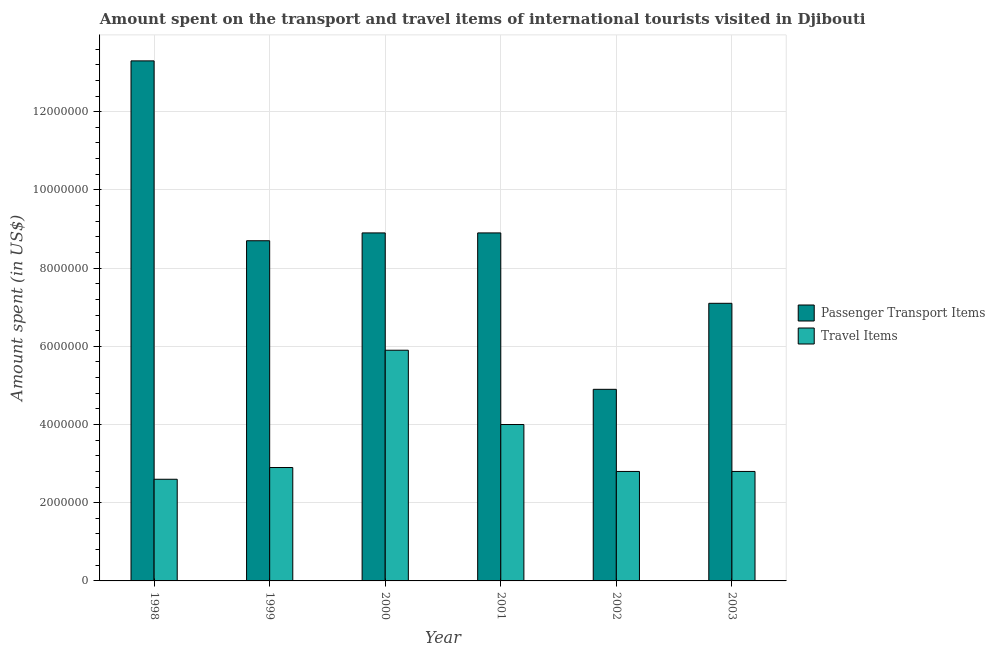How many groups of bars are there?
Your answer should be very brief. 6. What is the label of the 5th group of bars from the left?
Ensure brevity in your answer.  2002. What is the amount spent in travel items in 1999?
Provide a succinct answer. 2.90e+06. Across all years, what is the maximum amount spent in travel items?
Keep it short and to the point. 5.90e+06. Across all years, what is the minimum amount spent on passenger transport items?
Provide a short and direct response. 4.90e+06. What is the total amount spent in travel items in the graph?
Provide a succinct answer. 2.10e+07. What is the difference between the amount spent on passenger transport items in 1998 and that in 2002?
Provide a succinct answer. 8.40e+06. What is the difference between the amount spent in travel items in 1998 and the amount spent on passenger transport items in 1999?
Provide a succinct answer. -3.00e+05. What is the average amount spent on passenger transport items per year?
Offer a very short reply. 8.63e+06. In the year 1998, what is the difference between the amount spent on passenger transport items and amount spent in travel items?
Provide a short and direct response. 0. In how many years, is the amount spent on passenger transport items greater than 10400000 US$?
Ensure brevity in your answer.  1. What is the ratio of the amount spent in travel items in 1998 to that in 2003?
Give a very brief answer. 0.93. Is the difference between the amount spent on passenger transport items in 2000 and 2002 greater than the difference between the amount spent in travel items in 2000 and 2002?
Keep it short and to the point. No. What is the difference between the highest and the second highest amount spent on passenger transport items?
Keep it short and to the point. 4.40e+06. What is the difference between the highest and the lowest amount spent on passenger transport items?
Offer a very short reply. 8.40e+06. Is the sum of the amount spent on passenger transport items in 1999 and 2000 greater than the maximum amount spent in travel items across all years?
Give a very brief answer. Yes. What does the 1st bar from the left in 2000 represents?
Ensure brevity in your answer.  Passenger Transport Items. What does the 2nd bar from the right in 2001 represents?
Keep it short and to the point. Passenger Transport Items. Are all the bars in the graph horizontal?
Keep it short and to the point. No. How many years are there in the graph?
Your answer should be very brief. 6. What is the difference between two consecutive major ticks on the Y-axis?
Your response must be concise. 2.00e+06. Are the values on the major ticks of Y-axis written in scientific E-notation?
Offer a terse response. No. Where does the legend appear in the graph?
Your answer should be compact. Center right. How many legend labels are there?
Keep it short and to the point. 2. What is the title of the graph?
Ensure brevity in your answer.  Amount spent on the transport and travel items of international tourists visited in Djibouti. What is the label or title of the X-axis?
Keep it short and to the point. Year. What is the label or title of the Y-axis?
Keep it short and to the point. Amount spent (in US$). What is the Amount spent (in US$) of Passenger Transport Items in 1998?
Your answer should be compact. 1.33e+07. What is the Amount spent (in US$) of Travel Items in 1998?
Your answer should be compact. 2.60e+06. What is the Amount spent (in US$) of Passenger Transport Items in 1999?
Your answer should be compact. 8.70e+06. What is the Amount spent (in US$) of Travel Items in 1999?
Your response must be concise. 2.90e+06. What is the Amount spent (in US$) of Passenger Transport Items in 2000?
Make the answer very short. 8.90e+06. What is the Amount spent (in US$) in Travel Items in 2000?
Provide a short and direct response. 5.90e+06. What is the Amount spent (in US$) in Passenger Transport Items in 2001?
Keep it short and to the point. 8.90e+06. What is the Amount spent (in US$) in Travel Items in 2001?
Offer a terse response. 4.00e+06. What is the Amount spent (in US$) in Passenger Transport Items in 2002?
Ensure brevity in your answer.  4.90e+06. What is the Amount spent (in US$) of Travel Items in 2002?
Make the answer very short. 2.80e+06. What is the Amount spent (in US$) in Passenger Transport Items in 2003?
Ensure brevity in your answer.  7.10e+06. What is the Amount spent (in US$) of Travel Items in 2003?
Your answer should be compact. 2.80e+06. Across all years, what is the maximum Amount spent (in US$) of Passenger Transport Items?
Provide a short and direct response. 1.33e+07. Across all years, what is the maximum Amount spent (in US$) of Travel Items?
Provide a short and direct response. 5.90e+06. Across all years, what is the minimum Amount spent (in US$) in Passenger Transport Items?
Give a very brief answer. 4.90e+06. Across all years, what is the minimum Amount spent (in US$) in Travel Items?
Ensure brevity in your answer.  2.60e+06. What is the total Amount spent (in US$) of Passenger Transport Items in the graph?
Offer a terse response. 5.18e+07. What is the total Amount spent (in US$) in Travel Items in the graph?
Ensure brevity in your answer.  2.10e+07. What is the difference between the Amount spent (in US$) of Passenger Transport Items in 1998 and that in 1999?
Keep it short and to the point. 4.60e+06. What is the difference between the Amount spent (in US$) in Passenger Transport Items in 1998 and that in 2000?
Provide a short and direct response. 4.40e+06. What is the difference between the Amount spent (in US$) in Travel Items in 1998 and that in 2000?
Provide a succinct answer. -3.30e+06. What is the difference between the Amount spent (in US$) in Passenger Transport Items in 1998 and that in 2001?
Keep it short and to the point. 4.40e+06. What is the difference between the Amount spent (in US$) of Travel Items in 1998 and that in 2001?
Provide a short and direct response. -1.40e+06. What is the difference between the Amount spent (in US$) of Passenger Transport Items in 1998 and that in 2002?
Ensure brevity in your answer.  8.40e+06. What is the difference between the Amount spent (in US$) in Travel Items in 1998 and that in 2002?
Offer a very short reply. -2.00e+05. What is the difference between the Amount spent (in US$) of Passenger Transport Items in 1998 and that in 2003?
Provide a succinct answer. 6.20e+06. What is the difference between the Amount spent (in US$) in Travel Items in 1998 and that in 2003?
Provide a short and direct response. -2.00e+05. What is the difference between the Amount spent (in US$) of Passenger Transport Items in 1999 and that in 2001?
Offer a very short reply. -2.00e+05. What is the difference between the Amount spent (in US$) of Travel Items in 1999 and that in 2001?
Provide a succinct answer. -1.10e+06. What is the difference between the Amount spent (in US$) of Passenger Transport Items in 1999 and that in 2002?
Keep it short and to the point. 3.80e+06. What is the difference between the Amount spent (in US$) in Travel Items in 1999 and that in 2002?
Ensure brevity in your answer.  1.00e+05. What is the difference between the Amount spent (in US$) in Passenger Transport Items in 1999 and that in 2003?
Your response must be concise. 1.60e+06. What is the difference between the Amount spent (in US$) in Passenger Transport Items in 2000 and that in 2001?
Give a very brief answer. 0. What is the difference between the Amount spent (in US$) in Travel Items in 2000 and that in 2001?
Your response must be concise. 1.90e+06. What is the difference between the Amount spent (in US$) of Passenger Transport Items in 2000 and that in 2002?
Offer a terse response. 4.00e+06. What is the difference between the Amount spent (in US$) in Travel Items in 2000 and that in 2002?
Keep it short and to the point. 3.10e+06. What is the difference between the Amount spent (in US$) of Passenger Transport Items in 2000 and that in 2003?
Keep it short and to the point. 1.80e+06. What is the difference between the Amount spent (in US$) in Travel Items in 2000 and that in 2003?
Keep it short and to the point. 3.10e+06. What is the difference between the Amount spent (in US$) in Passenger Transport Items in 2001 and that in 2002?
Offer a very short reply. 4.00e+06. What is the difference between the Amount spent (in US$) in Travel Items in 2001 and that in 2002?
Make the answer very short. 1.20e+06. What is the difference between the Amount spent (in US$) of Passenger Transport Items in 2001 and that in 2003?
Your response must be concise. 1.80e+06. What is the difference between the Amount spent (in US$) in Travel Items in 2001 and that in 2003?
Ensure brevity in your answer.  1.20e+06. What is the difference between the Amount spent (in US$) of Passenger Transport Items in 2002 and that in 2003?
Provide a short and direct response. -2.20e+06. What is the difference between the Amount spent (in US$) of Travel Items in 2002 and that in 2003?
Offer a terse response. 0. What is the difference between the Amount spent (in US$) of Passenger Transport Items in 1998 and the Amount spent (in US$) of Travel Items in 1999?
Your answer should be compact. 1.04e+07. What is the difference between the Amount spent (in US$) in Passenger Transport Items in 1998 and the Amount spent (in US$) in Travel Items in 2000?
Your response must be concise. 7.40e+06. What is the difference between the Amount spent (in US$) of Passenger Transport Items in 1998 and the Amount spent (in US$) of Travel Items in 2001?
Make the answer very short. 9.30e+06. What is the difference between the Amount spent (in US$) in Passenger Transport Items in 1998 and the Amount spent (in US$) in Travel Items in 2002?
Keep it short and to the point. 1.05e+07. What is the difference between the Amount spent (in US$) of Passenger Transport Items in 1998 and the Amount spent (in US$) of Travel Items in 2003?
Your response must be concise. 1.05e+07. What is the difference between the Amount spent (in US$) in Passenger Transport Items in 1999 and the Amount spent (in US$) in Travel Items in 2000?
Your answer should be compact. 2.80e+06. What is the difference between the Amount spent (in US$) in Passenger Transport Items in 1999 and the Amount spent (in US$) in Travel Items in 2001?
Your response must be concise. 4.70e+06. What is the difference between the Amount spent (in US$) in Passenger Transport Items in 1999 and the Amount spent (in US$) in Travel Items in 2002?
Offer a terse response. 5.90e+06. What is the difference between the Amount spent (in US$) of Passenger Transport Items in 1999 and the Amount spent (in US$) of Travel Items in 2003?
Make the answer very short. 5.90e+06. What is the difference between the Amount spent (in US$) of Passenger Transport Items in 2000 and the Amount spent (in US$) of Travel Items in 2001?
Provide a succinct answer. 4.90e+06. What is the difference between the Amount spent (in US$) in Passenger Transport Items in 2000 and the Amount spent (in US$) in Travel Items in 2002?
Keep it short and to the point. 6.10e+06. What is the difference between the Amount spent (in US$) in Passenger Transport Items in 2000 and the Amount spent (in US$) in Travel Items in 2003?
Ensure brevity in your answer.  6.10e+06. What is the difference between the Amount spent (in US$) in Passenger Transport Items in 2001 and the Amount spent (in US$) in Travel Items in 2002?
Your response must be concise. 6.10e+06. What is the difference between the Amount spent (in US$) of Passenger Transport Items in 2001 and the Amount spent (in US$) of Travel Items in 2003?
Give a very brief answer. 6.10e+06. What is the difference between the Amount spent (in US$) of Passenger Transport Items in 2002 and the Amount spent (in US$) of Travel Items in 2003?
Provide a succinct answer. 2.10e+06. What is the average Amount spent (in US$) in Passenger Transport Items per year?
Make the answer very short. 8.63e+06. What is the average Amount spent (in US$) in Travel Items per year?
Your answer should be very brief. 3.50e+06. In the year 1998, what is the difference between the Amount spent (in US$) of Passenger Transport Items and Amount spent (in US$) of Travel Items?
Your response must be concise. 1.07e+07. In the year 1999, what is the difference between the Amount spent (in US$) in Passenger Transport Items and Amount spent (in US$) in Travel Items?
Give a very brief answer. 5.80e+06. In the year 2001, what is the difference between the Amount spent (in US$) of Passenger Transport Items and Amount spent (in US$) of Travel Items?
Ensure brevity in your answer.  4.90e+06. In the year 2002, what is the difference between the Amount spent (in US$) of Passenger Transport Items and Amount spent (in US$) of Travel Items?
Ensure brevity in your answer.  2.10e+06. In the year 2003, what is the difference between the Amount spent (in US$) in Passenger Transport Items and Amount spent (in US$) in Travel Items?
Ensure brevity in your answer.  4.30e+06. What is the ratio of the Amount spent (in US$) of Passenger Transport Items in 1998 to that in 1999?
Your response must be concise. 1.53. What is the ratio of the Amount spent (in US$) of Travel Items in 1998 to that in 1999?
Keep it short and to the point. 0.9. What is the ratio of the Amount spent (in US$) of Passenger Transport Items in 1998 to that in 2000?
Provide a succinct answer. 1.49. What is the ratio of the Amount spent (in US$) in Travel Items in 1998 to that in 2000?
Make the answer very short. 0.44. What is the ratio of the Amount spent (in US$) in Passenger Transport Items in 1998 to that in 2001?
Provide a short and direct response. 1.49. What is the ratio of the Amount spent (in US$) of Travel Items in 1998 to that in 2001?
Your answer should be very brief. 0.65. What is the ratio of the Amount spent (in US$) of Passenger Transport Items in 1998 to that in 2002?
Keep it short and to the point. 2.71. What is the ratio of the Amount spent (in US$) of Passenger Transport Items in 1998 to that in 2003?
Provide a succinct answer. 1.87. What is the ratio of the Amount spent (in US$) in Passenger Transport Items in 1999 to that in 2000?
Give a very brief answer. 0.98. What is the ratio of the Amount spent (in US$) in Travel Items in 1999 to that in 2000?
Your answer should be compact. 0.49. What is the ratio of the Amount spent (in US$) of Passenger Transport Items in 1999 to that in 2001?
Offer a terse response. 0.98. What is the ratio of the Amount spent (in US$) in Travel Items in 1999 to that in 2001?
Your answer should be very brief. 0.72. What is the ratio of the Amount spent (in US$) in Passenger Transport Items in 1999 to that in 2002?
Give a very brief answer. 1.78. What is the ratio of the Amount spent (in US$) in Travel Items in 1999 to that in 2002?
Offer a terse response. 1.04. What is the ratio of the Amount spent (in US$) in Passenger Transport Items in 1999 to that in 2003?
Keep it short and to the point. 1.23. What is the ratio of the Amount spent (in US$) in Travel Items in 1999 to that in 2003?
Offer a very short reply. 1.04. What is the ratio of the Amount spent (in US$) of Passenger Transport Items in 2000 to that in 2001?
Provide a succinct answer. 1. What is the ratio of the Amount spent (in US$) of Travel Items in 2000 to that in 2001?
Offer a very short reply. 1.48. What is the ratio of the Amount spent (in US$) of Passenger Transport Items in 2000 to that in 2002?
Keep it short and to the point. 1.82. What is the ratio of the Amount spent (in US$) of Travel Items in 2000 to that in 2002?
Give a very brief answer. 2.11. What is the ratio of the Amount spent (in US$) in Passenger Transport Items in 2000 to that in 2003?
Ensure brevity in your answer.  1.25. What is the ratio of the Amount spent (in US$) of Travel Items in 2000 to that in 2003?
Provide a succinct answer. 2.11. What is the ratio of the Amount spent (in US$) in Passenger Transport Items in 2001 to that in 2002?
Give a very brief answer. 1.82. What is the ratio of the Amount spent (in US$) in Travel Items in 2001 to that in 2002?
Offer a very short reply. 1.43. What is the ratio of the Amount spent (in US$) in Passenger Transport Items in 2001 to that in 2003?
Your response must be concise. 1.25. What is the ratio of the Amount spent (in US$) in Travel Items in 2001 to that in 2003?
Offer a very short reply. 1.43. What is the ratio of the Amount spent (in US$) of Passenger Transport Items in 2002 to that in 2003?
Make the answer very short. 0.69. What is the ratio of the Amount spent (in US$) in Travel Items in 2002 to that in 2003?
Your answer should be compact. 1. What is the difference between the highest and the second highest Amount spent (in US$) of Passenger Transport Items?
Your response must be concise. 4.40e+06. What is the difference between the highest and the second highest Amount spent (in US$) of Travel Items?
Provide a short and direct response. 1.90e+06. What is the difference between the highest and the lowest Amount spent (in US$) of Passenger Transport Items?
Ensure brevity in your answer.  8.40e+06. What is the difference between the highest and the lowest Amount spent (in US$) of Travel Items?
Make the answer very short. 3.30e+06. 